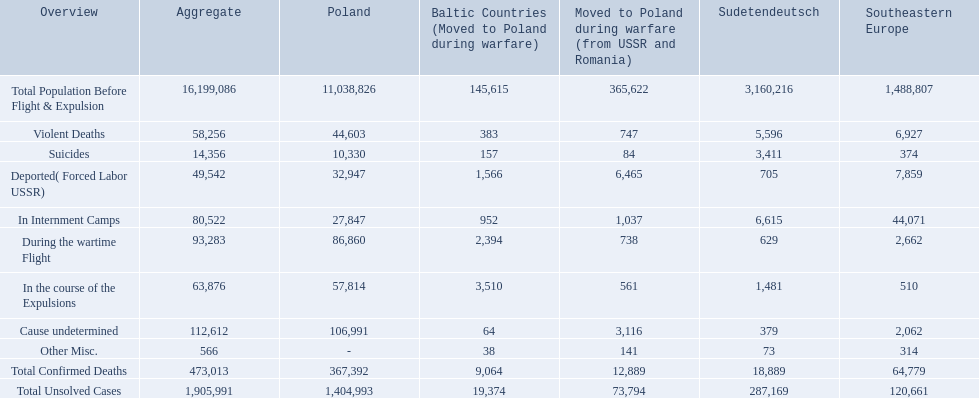What are all of the descriptions? Total Population Before Flight & Expulsion, Violent Deaths, Suicides, Deported( Forced Labor USSR), In Internment Camps, During the wartime Flight, In the course of the Expulsions, Cause undetermined, Other Misc., Total Confirmed Deaths, Total Unsolved Cases. What were their total number of deaths? 16,199,086, 58,256, 14,356, 49,542, 80,522, 93,283, 63,876, 112,612, 566, 473,013, 1,905,991. What about just from violent deaths? 58,256. 